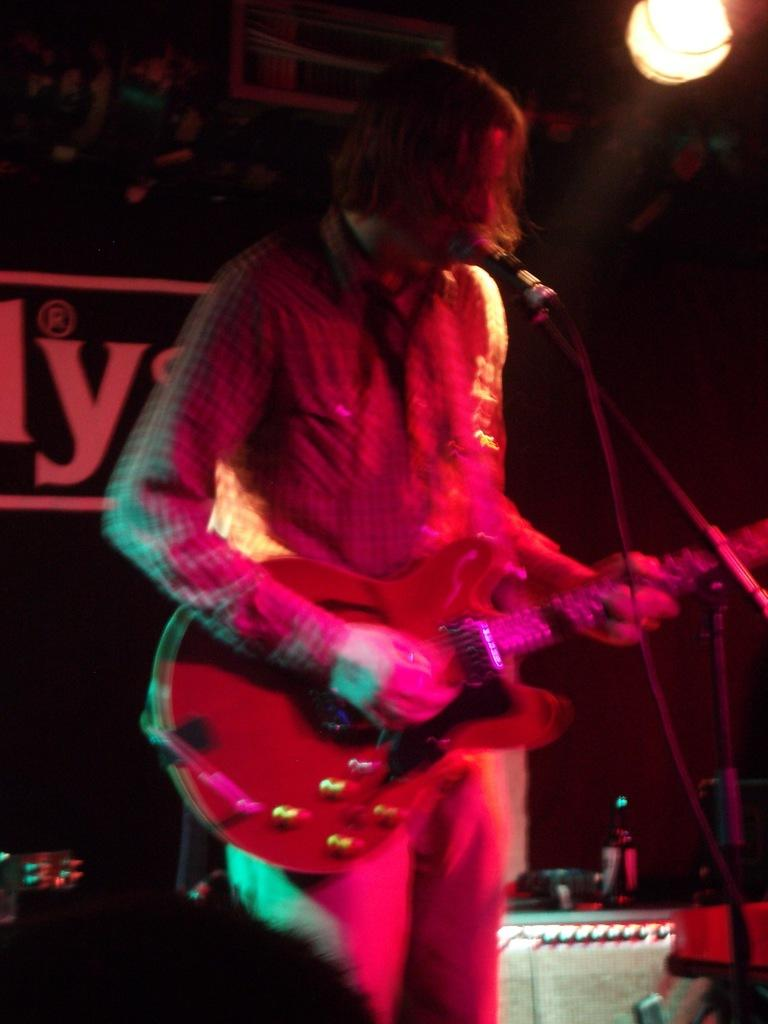What is the person in the image doing? The person is standing, holding a musical instrument, and singing in front of a microphone. What object is the person holding? The person is holding a musical instrument. What can be seen in the background of the image? There is a board and a light visible in the background. What type of sock is the representative wearing in the image? There is no representative or sock present in the image. What is the afterthought in the image? There is no afterthought present in the image. 